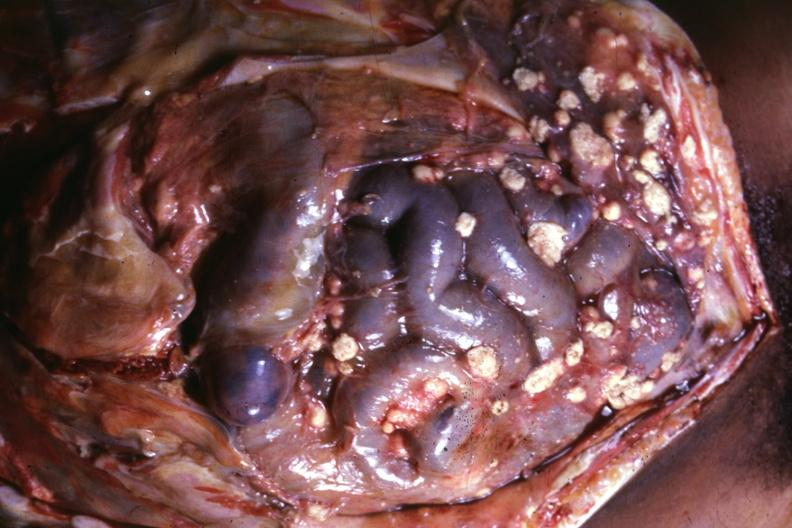what is present?
Answer the question using a single word or phrase. Carcinomatosis 